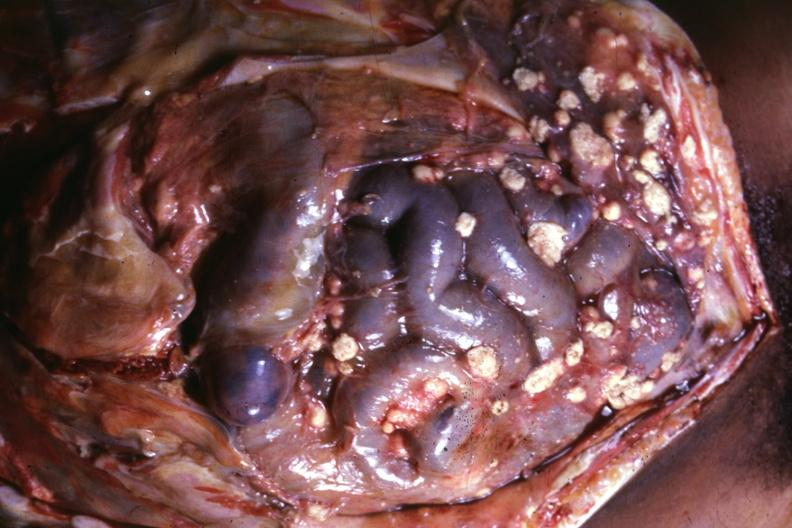what is present?
Answer the question using a single word or phrase. Carcinomatosis 